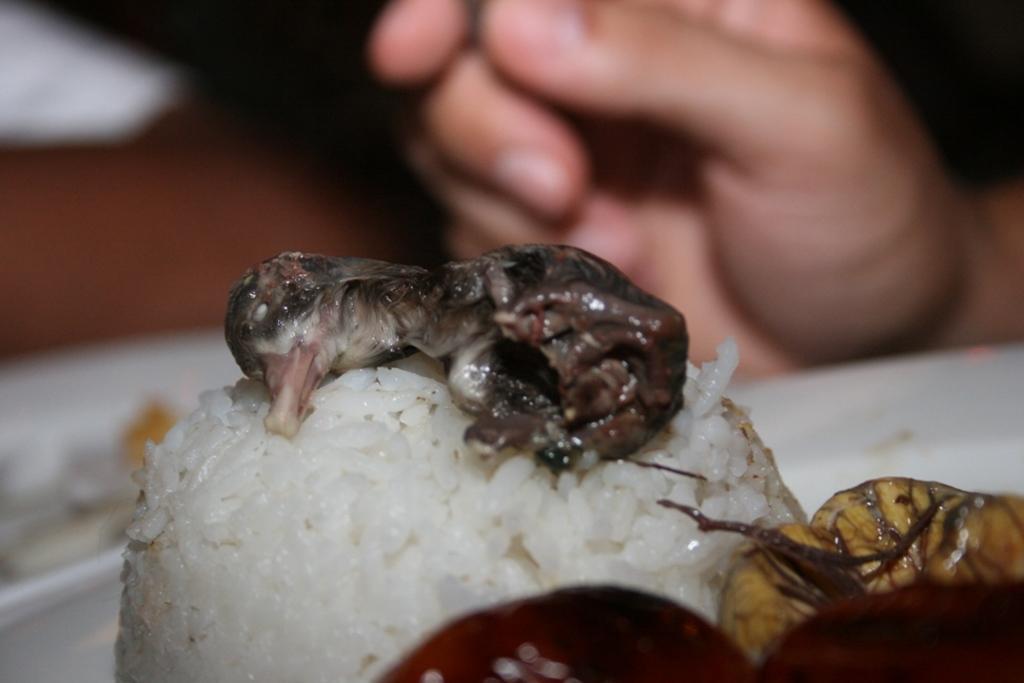Describe this image in one or two sentences. In this picture I can see food in the plate and I can see a human hand. 